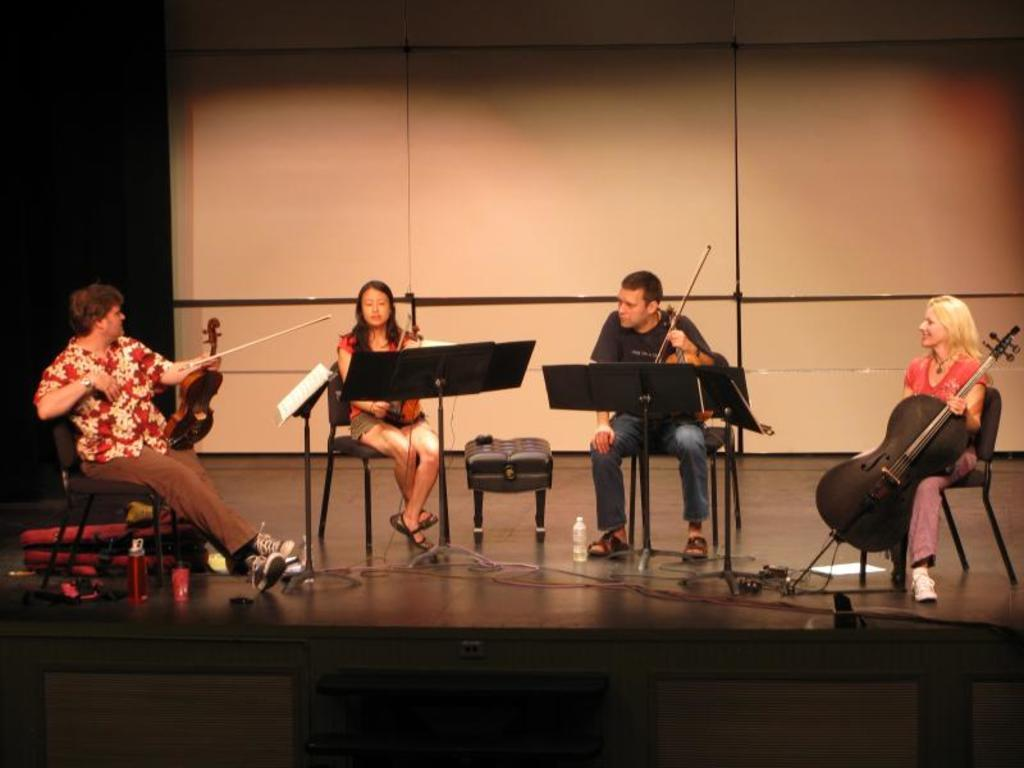How many people are sitting in the image? There are four persons sitting on chairs in the image. What are the people holding in their hands? The persons are holding musical instruments. What can be seen on the floor in the image? There are cables, a bottle, a paper, and a bag on the floor. Is there any furniture in the image that might be used for holding books? Yes, there is a book stand in the image. What type of stone can be seen in the image? There is no stone present in the image. Is there a sink visible in the image? No, there is no sink visible in the image. 